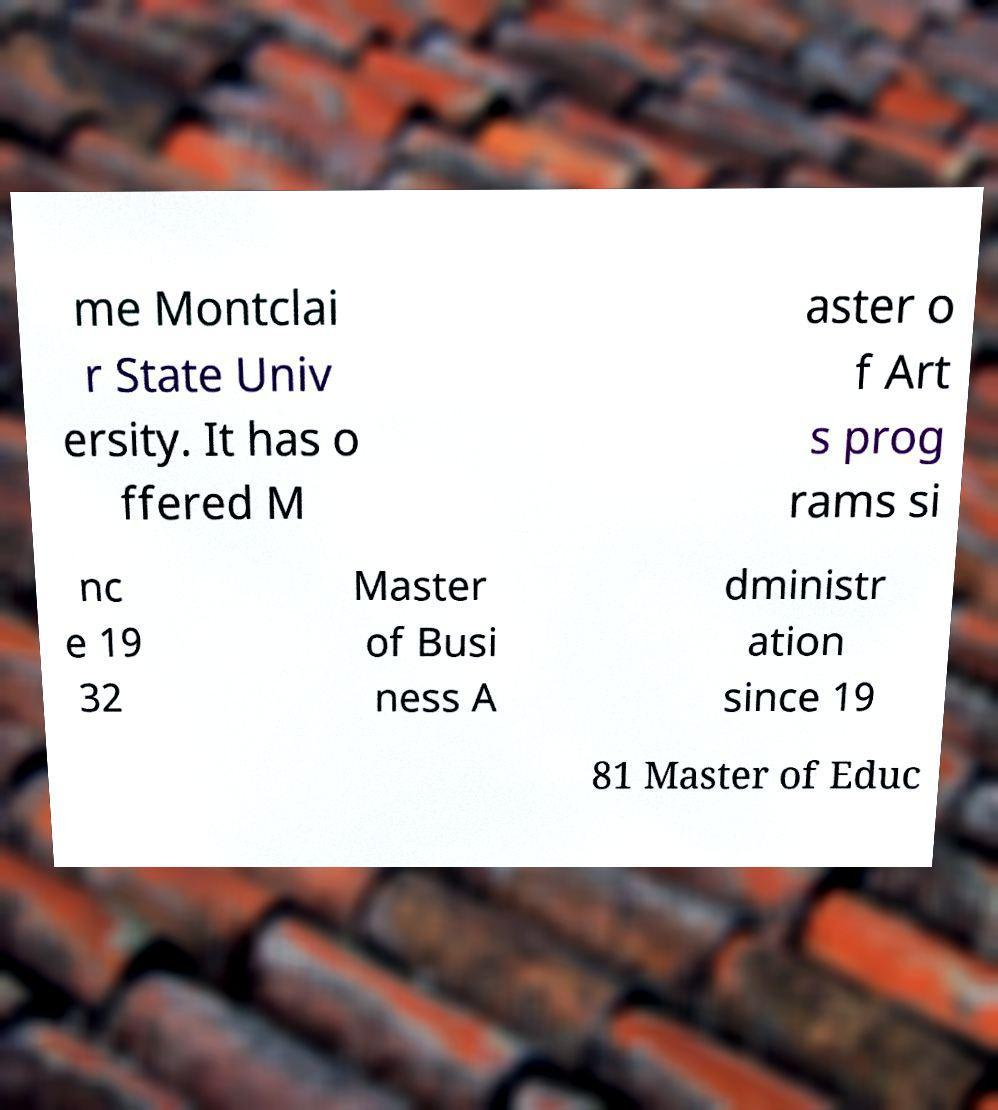For documentation purposes, I need the text within this image transcribed. Could you provide that? me Montclai r State Univ ersity. It has o ffered M aster o f Art s prog rams si nc e 19 32 Master of Busi ness A dministr ation since 19 81 Master of Educ 